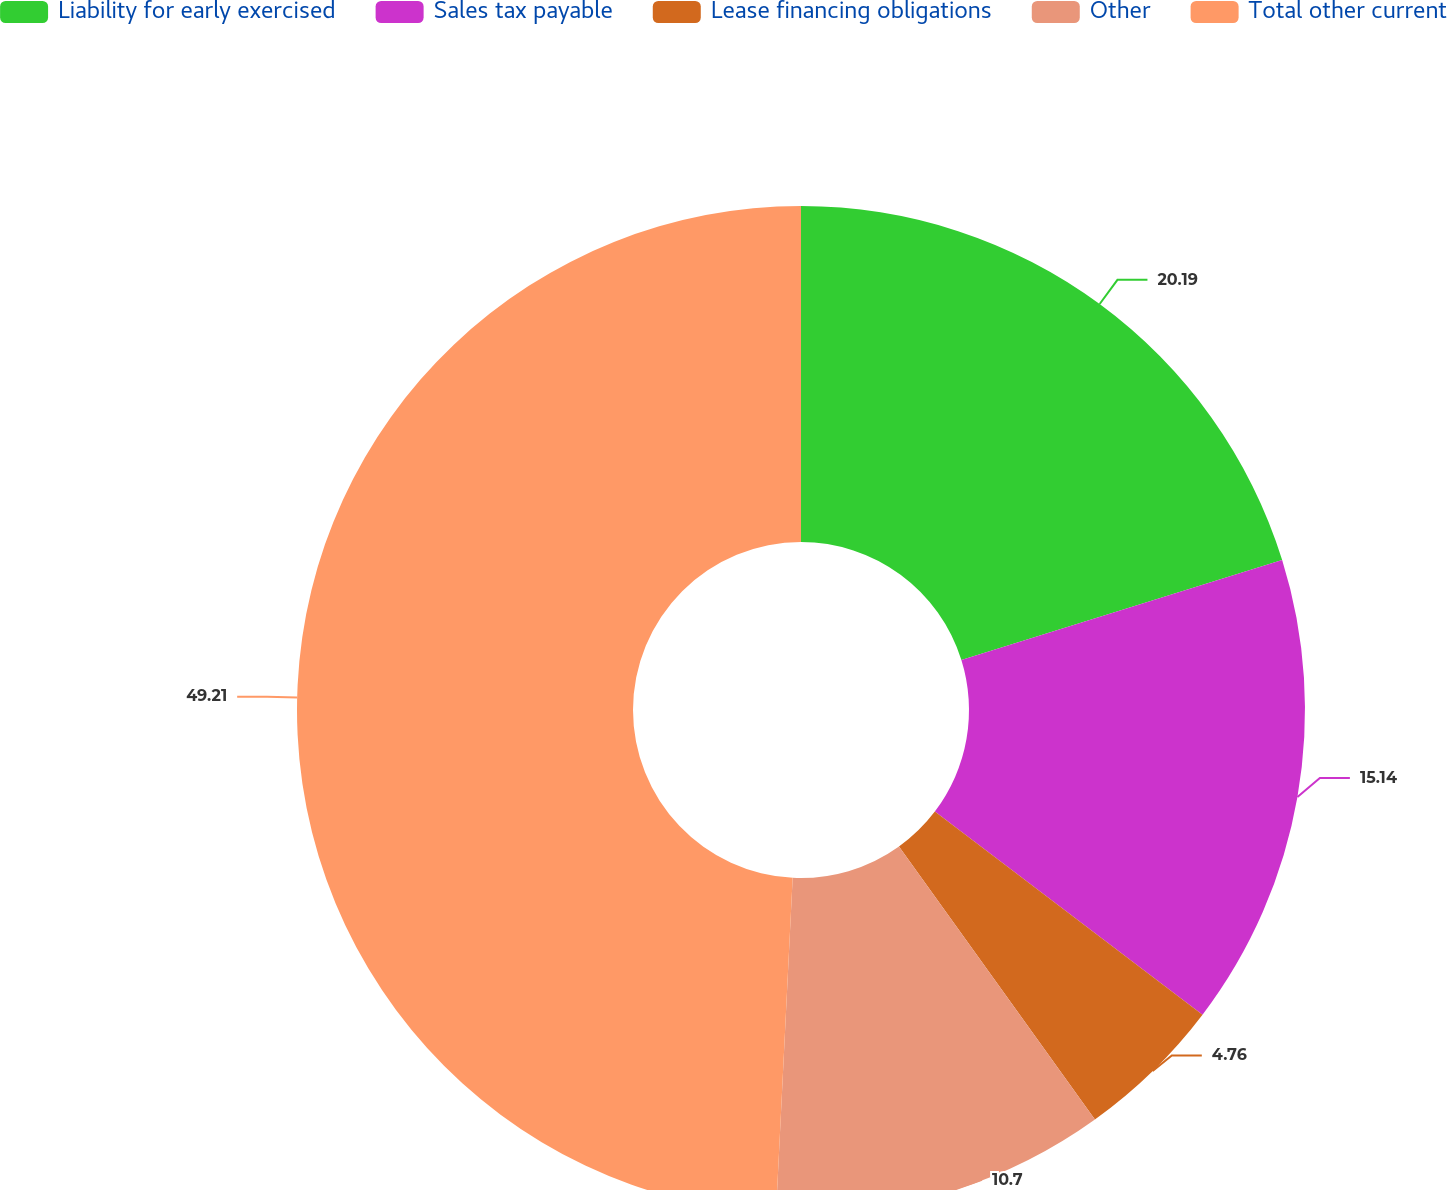Convert chart to OTSL. <chart><loc_0><loc_0><loc_500><loc_500><pie_chart><fcel>Liability for early exercised<fcel>Sales tax payable<fcel>Lease financing obligations<fcel>Other<fcel>Total other current<nl><fcel>20.19%<fcel>15.14%<fcel>4.76%<fcel>10.7%<fcel>49.21%<nl></chart> 